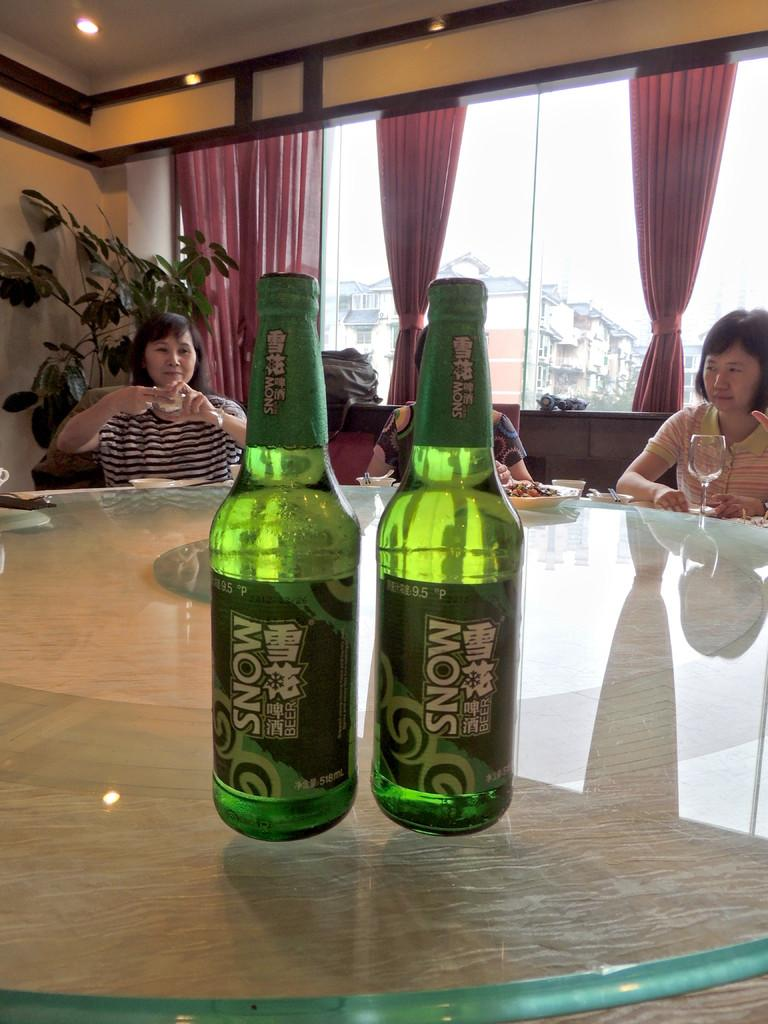What type of window treatment is present in the image? There are curtains in the image. What is located near the curtains? There is a window in the image. What type of vegetation is present in the image? There is a plant in the image. What type of furniture is present in the image? There are people sitting on sofas in the image. What type of surface is present in the image? There is a table in the image. What objects are on the table? There are two bottles on the table. What type of flight is depicted in the image? There is no flight depicted in the image; it features curtains, a window, a plant, people sitting on sofas, a table, and two bottles on the table. What type of chalk is being used by the people sitting on the sofa? There is no chalk present in the image; the people are sitting on sofas, but there is no indication of any chalk-related activity. 